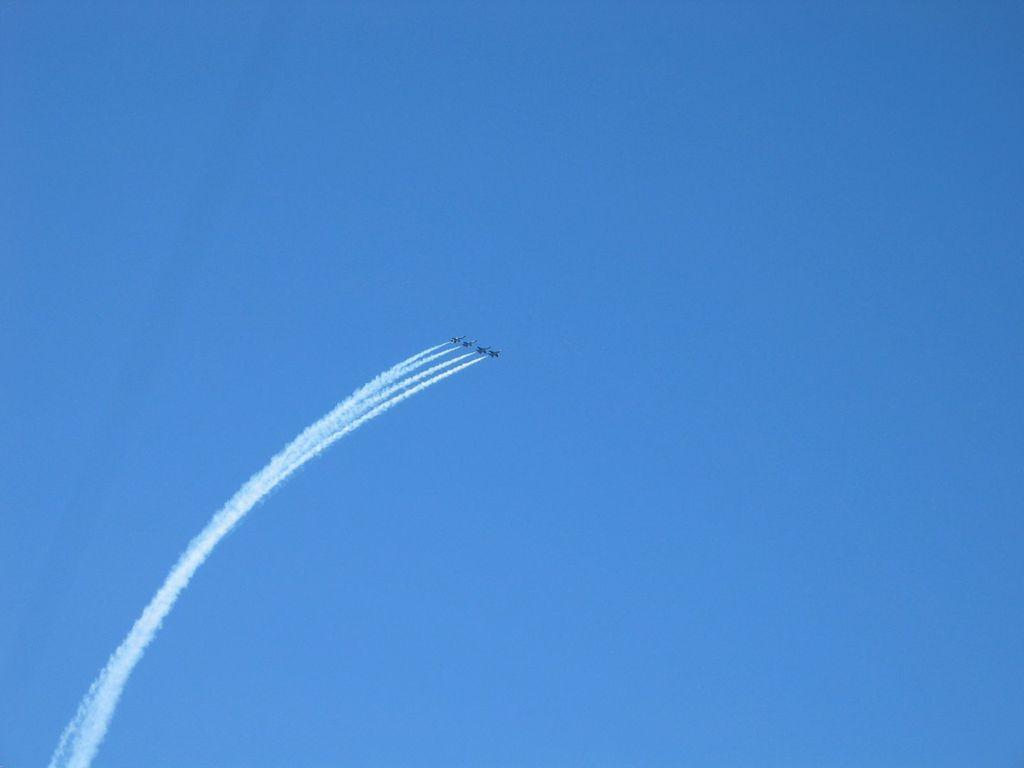What is the main subject of the image? The main subject of the image is jets. What are the jets doing in the image? The jets are moving in the air. What color is the sky in the image? The sky is blue in the image. Can you tell me how many sponges are being used by the farmer in the image? There is no farmer or sponge present in the image; it features jets moving in the blue sky. 